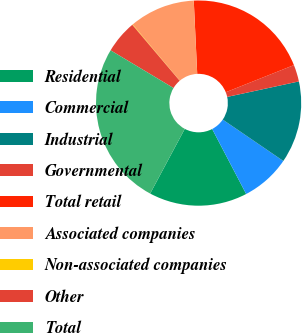<chart> <loc_0><loc_0><loc_500><loc_500><pie_chart><fcel>Residential<fcel>Commercial<fcel>Industrial<fcel>Governmental<fcel>Total retail<fcel>Associated companies<fcel>Non-associated companies<fcel>Other<fcel>Total<nl><fcel>15.5%<fcel>7.79%<fcel>12.93%<fcel>2.65%<fcel>19.72%<fcel>10.36%<fcel>0.08%<fcel>5.22%<fcel>25.78%<nl></chart> 